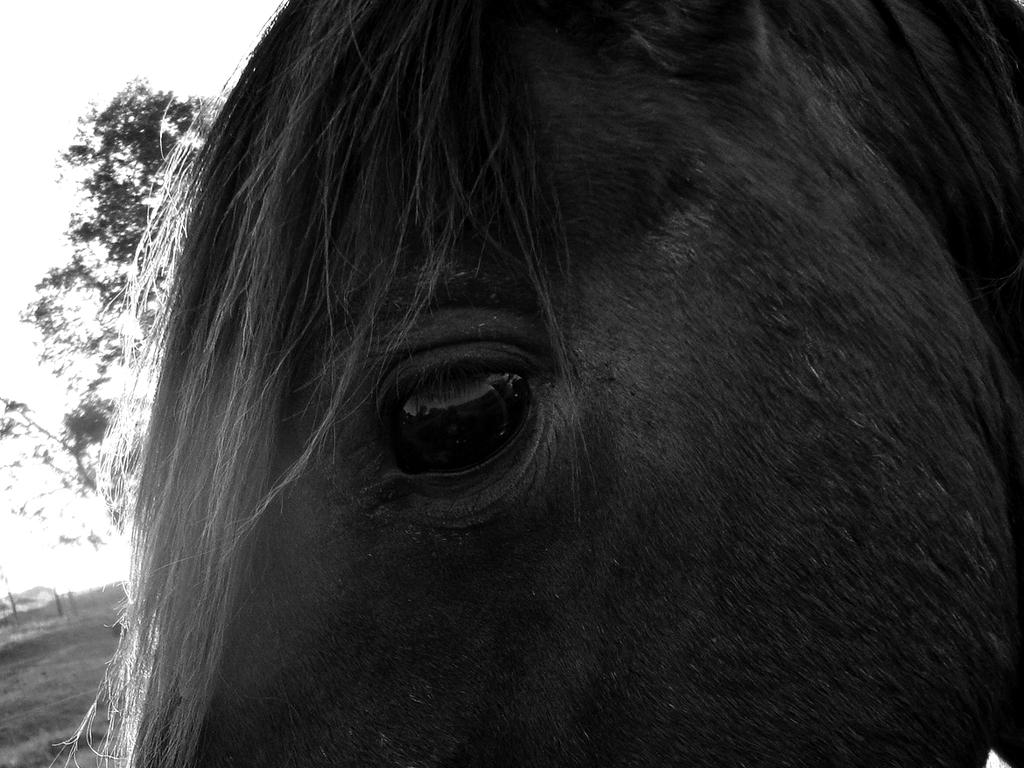What is the color scheme of the image? The image is black and white. What type of living creature can be seen in the image? There is an animal in the image. Where is the tree located in the image? There is a tree on the left side of the image. What can be seen in the background of the image? There is a sky visible in the background of the image. What book is the animal reading in the image? There is no book present in the image, and the animal is not shown reading. 